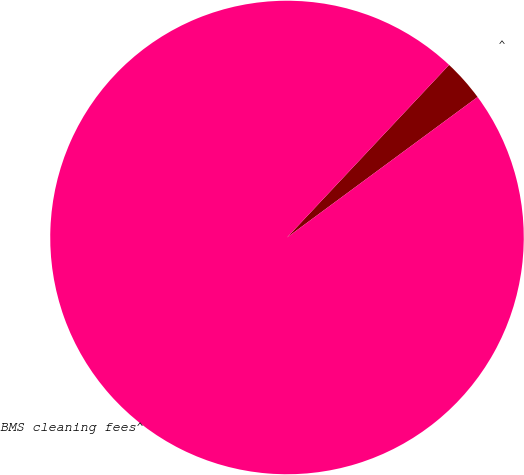Convert chart. <chart><loc_0><loc_0><loc_500><loc_500><pie_chart><fcel>^<fcel>BMS cleaning fees^<nl><fcel>2.89%<fcel>97.11%<nl></chart> 